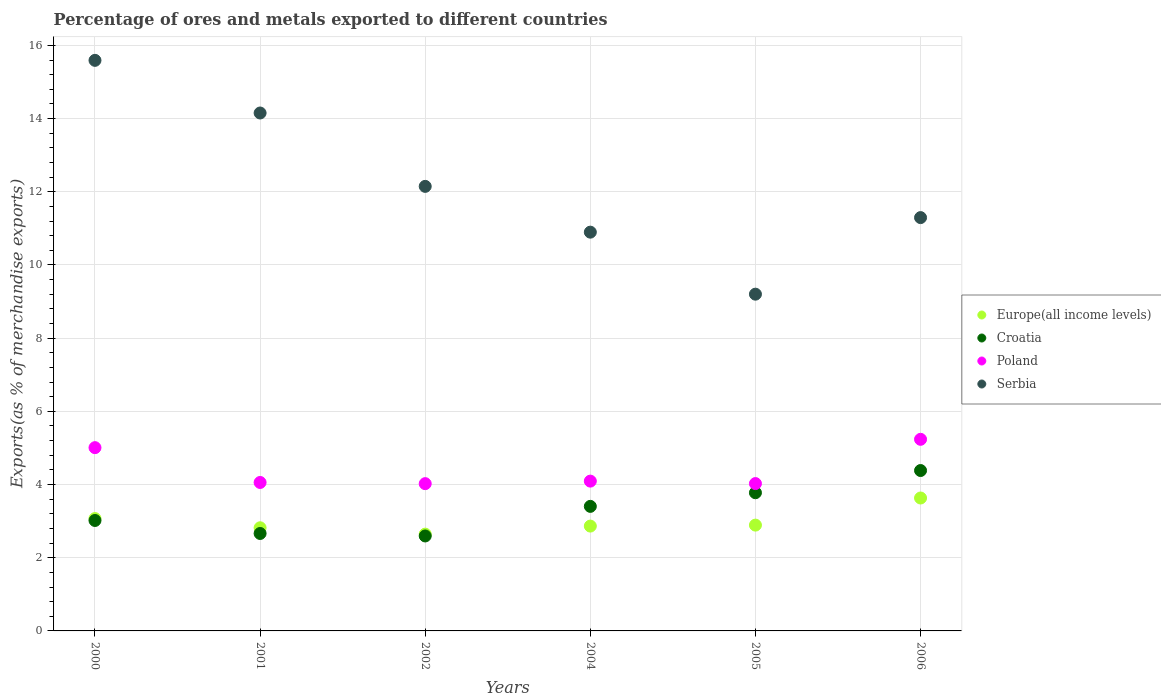Is the number of dotlines equal to the number of legend labels?
Your answer should be compact. Yes. What is the percentage of exports to different countries in Croatia in 2001?
Your response must be concise. 2.66. Across all years, what is the maximum percentage of exports to different countries in Europe(all income levels)?
Your answer should be very brief. 3.63. Across all years, what is the minimum percentage of exports to different countries in Croatia?
Your response must be concise. 2.59. In which year was the percentage of exports to different countries in Croatia maximum?
Keep it short and to the point. 2006. What is the total percentage of exports to different countries in Europe(all income levels) in the graph?
Offer a very short reply. 17.92. What is the difference between the percentage of exports to different countries in Poland in 2002 and that in 2006?
Keep it short and to the point. -1.21. What is the difference between the percentage of exports to different countries in Serbia in 2004 and the percentage of exports to different countries in Europe(all income levels) in 2000?
Keep it short and to the point. 7.83. What is the average percentage of exports to different countries in Poland per year?
Ensure brevity in your answer.  4.41. In the year 2004, what is the difference between the percentage of exports to different countries in Croatia and percentage of exports to different countries in Poland?
Your response must be concise. -0.69. In how many years, is the percentage of exports to different countries in Europe(all income levels) greater than 9.2 %?
Provide a short and direct response. 0. What is the ratio of the percentage of exports to different countries in Croatia in 2004 to that in 2005?
Make the answer very short. 0.9. What is the difference between the highest and the second highest percentage of exports to different countries in Europe(all income levels)?
Provide a succinct answer. 0.56. What is the difference between the highest and the lowest percentage of exports to different countries in Europe(all income levels)?
Offer a very short reply. 0.99. In how many years, is the percentage of exports to different countries in Serbia greater than the average percentage of exports to different countries in Serbia taken over all years?
Ensure brevity in your answer.  2. Is the sum of the percentage of exports to different countries in Poland in 2000 and 2002 greater than the maximum percentage of exports to different countries in Croatia across all years?
Offer a terse response. Yes. Does the percentage of exports to different countries in Croatia monotonically increase over the years?
Your answer should be compact. No. Are the values on the major ticks of Y-axis written in scientific E-notation?
Provide a succinct answer. No. Does the graph contain grids?
Offer a very short reply. Yes. How many legend labels are there?
Provide a succinct answer. 4. How are the legend labels stacked?
Your answer should be compact. Vertical. What is the title of the graph?
Give a very brief answer. Percentage of ores and metals exported to different countries. Does "Cayman Islands" appear as one of the legend labels in the graph?
Give a very brief answer. No. What is the label or title of the Y-axis?
Make the answer very short. Exports(as % of merchandise exports). What is the Exports(as % of merchandise exports) in Europe(all income levels) in 2000?
Your answer should be compact. 3.07. What is the Exports(as % of merchandise exports) in Croatia in 2000?
Offer a very short reply. 3.02. What is the Exports(as % of merchandise exports) of Poland in 2000?
Ensure brevity in your answer.  5.01. What is the Exports(as % of merchandise exports) of Serbia in 2000?
Offer a terse response. 15.59. What is the Exports(as % of merchandise exports) in Europe(all income levels) in 2001?
Make the answer very short. 2.82. What is the Exports(as % of merchandise exports) in Croatia in 2001?
Offer a terse response. 2.66. What is the Exports(as % of merchandise exports) in Poland in 2001?
Provide a short and direct response. 4.06. What is the Exports(as % of merchandise exports) of Serbia in 2001?
Offer a very short reply. 14.15. What is the Exports(as % of merchandise exports) in Europe(all income levels) in 2002?
Offer a very short reply. 2.65. What is the Exports(as % of merchandise exports) of Croatia in 2002?
Keep it short and to the point. 2.59. What is the Exports(as % of merchandise exports) in Poland in 2002?
Provide a short and direct response. 4.02. What is the Exports(as % of merchandise exports) in Serbia in 2002?
Your response must be concise. 12.15. What is the Exports(as % of merchandise exports) in Europe(all income levels) in 2004?
Keep it short and to the point. 2.86. What is the Exports(as % of merchandise exports) in Croatia in 2004?
Your response must be concise. 3.4. What is the Exports(as % of merchandise exports) in Poland in 2004?
Make the answer very short. 4.09. What is the Exports(as % of merchandise exports) in Serbia in 2004?
Keep it short and to the point. 10.9. What is the Exports(as % of merchandise exports) in Europe(all income levels) in 2005?
Make the answer very short. 2.89. What is the Exports(as % of merchandise exports) of Croatia in 2005?
Provide a succinct answer. 3.78. What is the Exports(as % of merchandise exports) in Poland in 2005?
Your answer should be very brief. 4.03. What is the Exports(as % of merchandise exports) in Serbia in 2005?
Your answer should be compact. 9.2. What is the Exports(as % of merchandise exports) of Europe(all income levels) in 2006?
Provide a succinct answer. 3.63. What is the Exports(as % of merchandise exports) in Croatia in 2006?
Offer a terse response. 4.38. What is the Exports(as % of merchandise exports) of Poland in 2006?
Your answer should be very brief. 5.24. What is the Exports(as % of merchandise exports) in Serbia in 2006?
Offer a very short reply. 11.29. Across all years, what is the maximum Exports(as % of merchandise exports) in Europe(all income levels)?
Offer a terse response. 3.63. Across all years, what is the maximum Exports(as % of merchandise exports) in Croatia?
Your answer should be compact. 4.38. Across all years, what is the maximum Exports(as % of merchandise exports) of Poland?
Your answer should be very brief. 5.24. Across all years, what is the maximum Exports(as % of merchandise exports) in Serbia?
Your response must be concise. 15.59. Across all years, what is the minimum Exports(as % of merchandise exports) of Europe(all income levels)?
Offer a terse response. 2.65. Across all years, what is the minimum Exports(as % of merchandise exports) in Croatia?
Keep it short and to the point. 2.59. Across all years, what is the minimum Exports(as % of merchandise exports) of Poland?
Your response must be concise. 4.02. Across all years, what is the minimum Exports(as % of merchandise exports) in Serbia?
Offer a very short reply. 9.2. What is the total Exports(as % of merchandise exports) of Europe(all income levels) in the graph?
Make the answer very short. 17.92. What is the total Exports(as % of merchandise exports) of Croatia in the graph?
Your answer should be compact. 19.84. What is the total Exports(as % of merchandise exports) in Poland in the graph?
Provide a short and direct response. 26.45. What is the total Exports(as % of merchandise exports) of Serbia in the graph?
Ensure brevity in your answer.  73.29. What is the difference between the Exports(as % of merchandise exports) in Europe(all income levels) in 2000 and that in 2001?
Your answer should be very brief. 0.25. What is the difference between the Exports(as % of merchandise exports) of Croatia in 2000 and that in 2001?
Offer a terse response. 0.36. What is the difference between the Exports(as % of merchandise exports) of Poland in 2000 and that in 2001?
Offer a terse response. 0.95. What is the difference between the Exports(as % of merchandise exports) of Serbia in 2000 and that in 2001?
Your response must be concise. 1.44. What is the difference between the Exports(as % of merchandise exports) of Europe(all income levels) in 2000 and that in 2002?
Keep it short and to the point. 0.43. What is the difference between the Exports(as % of merchandise exports) of Croatia in 2000 and that in 2002?
Your response must be concise. 0.42. What is the difference between the Exports(as % of merchandise exports) in Poland in 2000 and that in 2002?
Make the answer very short. 0.98. What is the difference between the Exports(as % of merchandise exports) in Serbia in 2000 and that in 2002?
Provide a succinct answer. 3.44. What is the difference between the Exports(as % of merchandise exports) in Europe(all income levels) in 2000 and that in 2004?
Your answer should be compact. 0.21. What is the difference between the Exports(as % of merchandise exports) in Croatia in 2000 and that in 2004?
Your response must be concise. -0.39. What is the difference between the Exports(as % of merchandise exports) in Poland in 2000 and that in 2004?
Give a very brief answer. 0.91. What is the difference between the Exports(as % of merchandise exports) of Serbia in 2000 and that in 2004?
Ensure brevity in your answer.  4.69. What is the difference between the Exports(as % of merchandise exports) of Europe(all income levels) in 2000 and that in 2005?
Your answer should be very brief. 0.18. What is the difference between the Exports(as % of merchandise exports) in Croatia in 2000 and that in 2005?
Make the answer very short. -0.76. What is the difference between the Exports(as % of merchandise exports) in Poland in 2000 and that in 2005?
Your answer should be very brief. 0.98. What is the difference between the Exports(as % of merchandise exports) in Serbia in 2000 and that in 2005?
Give a very brief answer. 6.39. What is the difference between the Exports(as % of merchandise exports) of Europe(all income levels) in 2000 and that in 2006?
Your answer should be very brief. -0.56. What is the difference between the Exports(as % of merchandise exports) in Croatia in 2000 and that in 2006?
Ensure brevity in your answer.  -1.36. What is the difference between the Exports(as % of merchandise exports) in Poland in 2000 and that in 2006?
Offer a terse response. -0.23. What is the difference between the Exports(as % of merchandise exports) of Serbia in 2000 and that in 2006?
Provide a short and direct response. 4.3. What is the difference between the Exports(as % of merchandise exports) of Europe(all income levels) in 2001 and that in 2002?
Offer a terse response. 0.17. What is the difference between the Exports(as % of merchandise exports) of Croatia in 2001 and that in 2002?
Your answer should be compact. 0.07. What is the difference between the Exports(as % of merchandise exports) of Poland in 2001 and that in 2002?
Provide a short and direct response. 0.03. What is the difference between the Exports(as % of merchandise exports) of Serbia in 2001 and that in 2002?
Make the answer very short. 2.01. What is the difference between the Exports(as % of merchandise exports) of Europe(all income levels) in 2001 and that in 2004?
Provide a succinct answer. -0.05. What is the difference between the Exports(as % of merchandise exports) in Croatia in 2001 and that in 2004?
Keep it short and to the point. -0.74. What is the difference between the Exports(as % of merchandise exports) in Poland in 2001 and that in 2004?
Your answer should be very brief. -0.04. What is the difference between the Exports(as % of merchandise exports) of Serbia in 2001 and that in 2004?
Your answer should be compact. 3.26. What is the difference between the Exports(as % of merchandise exports) in Europe(all income levels) in 2001 and that in 2005?
Your answer should be very brief. -0.07. What is the difference between the Exports(as % of merchandise exports) of Croatia in 2001 and that in 2005?
Offer a terse response. -1.11. What is the difference between the Exports(as % of merchandise exports) in Poland in 2001 and that in 2005?
Provide a succinct answer. 0.03. What is the difference between the Exports(as % of merchandise exports) in Serbia in 2001 and that in 2005?
Your answer should be very brief. 4.95. What is the difference between the Exports(as % of merchandise exports) in Europe(all income levels) in 2001 and that in 2006?
Make the answer very short. -0.81. What is the difference between the Exports(as % of merchandise exports) in Croatia in 2001 and that in 2006?
Make the answer very short. -1.72. What is the difference between the Exports(as % of merchandise exports) in Poland in 2001 and that in 2006?
Give a very brief answer. -1.18. What is the difference between the Exports(as % of merchandise exports) in Serbia in 2001 and that in 2006?
Offer a terse response. 2.86. What is the difference between the Exports(as % of merchandise exports) in Europe(all income levels) in 2002 and that in 2004?
Your response must be concise. -0.22. What is the difference between the Exports(as % of merchandise exports) in Croatia in 2002 and that in 2004?
Keep it short and to the point. -0.81. What is the difference between the Exports(as % of merchandise exports) in Poland in 2002 and that in 2004?
Offer a very short reply. -0.07. What is the difference between the Exports(as % of merchandise exports) in Serbia in 2002 and that in 2004?
Your response must be concise. 1.25. What is the difference between the Exports(as % of merchandise exports) in Europe(all income levels) in 2002 and that in 2005?
Provide a short and direct response. -0.25. What is the difference between the Exports(as % of merchandise exports) of Croatia in 2002 and that in 2005?
Your response must be concise. -1.18. What is the difference between the Exports(as % of merchandise exports) of Poland in 2002 and that in 2005?
Make the answer very short. -0. What is the difference between the Exports(as % of merchandise exports) in Serbia in 2002 and that in 2005?
Offer a terse response. 2.95. What is the difference between the Exports(as % of merchandise exports) of Europe(all income levels) in 2002 and that in 2006?
Give a very brief answer. -0.99. What is the difference between the Exports(as % of merchandise exports) of Croatia in 2002 and that in 2006?
Your answer should be very brief. -1.79. What is the difference between the Exports(as % of merchandise exports) of Poland in 2002 and that in 2006?
Make the answer very short. -1.21. What is the difference between the Exports(as % of merchandise exports) of Serbia in 2002 and that in 2006?
Your response must be concise. 0.85. What is the difference between the Exports(as % of merchandise exports) of Europe(all income levels) in 2004 and that in 2005?
Offer a terse response. -0.03. What is the difference between the Exports(as % of merchandise exports) of Croatia in 2004 and that in 2005?
Provide a succinct answer. -0.37. What is the difference between the Exports(as % of merchandise exports) of Poland in 2004 and that in 2005?
Give a very brief answer. 0.07. What is the difference between the Exports(as % of merchandise exports) in Serbia in 2004 and that in 2005?
Your answer should be very brief. 1.69. What is the difference between the Exports(as % of merchandise exports) of Europe(all income levels) in 2004 and that in 2006?
Keep it short and to the point. -0.77. What is the difference between the Exports(as % of merchandise exports) in Croatia in 2004 and that in 2006?
Give a very brief answer. -0.98. What is the difference between the Exports(as % of merchandise exports) in Poland in 2004 and that in 2006?
Your response must be concise. -1.14. What is the difference between the Exports(as % of merchandise exports) in Serbia in 2004 and that in 2006?
Provide a short and direct response. -0.4. What is the difference between the Exports(as % of merchandise exports) of Europe(all income levels) in 2005 and that in 2006?
Your answer should be very brief. -0.74. What is the difference between the Exports(as % of merchandise exports) of Croatia in 2005 and that in 2006?
Ensure brevity in your answer.  -0.61. What is the difference between the Exports(as % of merchandise exports) of Poland in 2005 and that in 2006?
Make the answer very short. -1.21. What is the difference between the Exports(as % of merchandise exports) of Serbia in 2005 and that in 2006?
Ensure brevity in your answer.  -2.09. What is the difference between the Exports(as % of merchandise exports) in Europe(all income levels) in 2000 and the Exports(as % of merchandise exports) in Croatia in 2001?
Give a very brief answer. 0.41. What is the difference between the Exports(as % of merchandise exports) in Europe(all income levels) in 2000 and the Exports(as % of merchandise exports) in Poland in 2001?
Make the answer very short. -0.99. What is the difference between the Exports(as % of merchandise exports) of Europe(all income levels) in 2000 and the Exports(as % of merchandise exports) of Serbia in 2001?
Offer a terse response. -11.08. What is the difference between the Exports(as % of merchandise exports) in Croatia in 2000 and the Exports(as % of merchandise exports) in Poland in 2001?
Provide a short and direct response. -1.04. What is the difference between the Exports(as % of merchandise exports) of Croatia in 2000 and the Exports(as % of merchandise exports) of Serbia in 2001?
Keep it short and to the point. -11.14. What is the difference between the Exports(as % of merchandise exports) of Poland in 2000 and the Exports(as % of merchandise exports) of Serbia in 2001?
Give a very brief answer. -9.14. What is the difference between the Exports(as % of merchandise exports) in Europe(all income levels) in 2000 and the Exports(as % of merchandise exports) in Croatia in 2002?
Offer a terse response. 0.48. What is the difference between the Exports(as % of merchandise exports) in Europe(all income levels) in 2000 and the Exports(as % of merchandise exports) in Poland in 2002?
Your answer should be very brief. -0.95. What is the difference between the Exports(as % of merchandise exports) in Europe(all income levels) in 2000 and the Exports(as % of merchandise exports) in Serbia in 2002?
Provide a succinct answer. -9.08. What is the difference between the Exports(as % of merchandise exports) in Croatia in 2000 and the Exports(as % of merchandise exports) in Poland in 2002?
Give a very brief answer. -1.01. What is the difference between the Exports(as % of merchandise exports) in Croatia in 2000 and the Exports(as % of merchandise exports) in Serbia in 2002?
Ensure brevity in your answer.  -9.13. What is the difference between the Exports(as % of merchandise exports) in Poland in 2000 and the Exports(as % of merchandise exports) in Serbia in 2002?
Your answer should be compact. -7.14. What is the difference between the Exports(as % of merchandise exports) in Europe(all income levels) in 2000 and the Exports(as % of merchandise exports) in Croatia in 2004?
Offer a terse response. -0.33. What is the difference between the Exports(as % of merchandise exports) in Europe(all income levels) in 2000 and the Exports(as % of merchandise exports) in Poland in 2004?
Keep it short and to the point. -1.02. What is the difference between the Exports(as % of merchandise exports) of Europe(all income levels) in 2000 and the Exports(as % of merchandise exports) of Serbia in 2004?
Your answer should be very brief. -7.83. What is the difference between the Exports(as % of merchandise exports) of Croatia in 2000 and the Exports(as % of merchandise exports) of Poland in 2004?
Provide a short and direct response. -1.08. What is the difference between the Exports(as % of merchandise exports) of Croatia in 2000 and the Exports(as % of merchandise exports) of Serbia in 2004?
Make the answer very short. -7.88. What is the difference between the Exports(as % of merchandise exports) of Poland in 2000 and the Exports(as % of merchandise exports) of Serbia in 2004?
Provide a succinct answer. -5.89. What is the difference between the Exports(as % of merchandise exports) in Europe(all income levels) in 2000 and the Exports(as % of merchandise exports) in Croatia in 2005?
Offer a terse response. -0.71. What is the difference between the Exports(as % of merchandise exports) of Europe(all income levels) in 2000 and the Exports(as % of merchandise exports) of Poland in 2005?
Provide a short and direct response. -0.96. What is the difference between the Exports(as % of merchandise exports) in Europe(all income levels) in 2000 and the Exports(as % of merchandise exports) in Serbia in 2005?
Provide a succinct answer. -6.13. What is the difference between the Exports(as % of merchandise exports) of Croatia in 2000 and the Exports(as % of merchandise exports) of Poland in 2005?
Make the answer very short. -1.01. What is the difference between the Exports(as % of merchandise exports) of Croatia in 2000 and the Exports(as % of merchandise exports) of Serbia in 2005?
Your answer should be compact. -6.18. What is the difference between the Exports(as % of merchandise exports) of Poland in 2000 and the Exports(as % of merchandise exports) of Serbia in 2005?
Offer a terse response. -4.19. What is the difference between the Exports(as % of merchandise exports) of Europe(all income levels) in 2000 and the Exports(as % of merchandise exports) of Croatia in 2006?
Your response must be concise. -1.31. What is the difference between the Exports(as % of merchandise exports) of Europe(all income levels) in 2000 and the Exports(as % of merchandise exports) of Poland in 2006?
Your answer should be very brief. -2.17. What is the difference between the Exports(as % of merchandise exports) of Europe(all income levels) in 2000 and the Exports(as % of merchandise exports) of Serbia in 2006?
Keep it short and to the point. -8.22. What is the difference between the Exports(as % of merchandise exports) of Croatia in 2000 and the Exports(as % of merchandise exports) of Poland in 2006?
Provide a succinct answer. -2.22. What is the difference between the Exports(as % of merchandise exports) of Croatia in 2000 and the Exports(as % of merchandise exports) of Serbia in 2006?
Your response must be concise. -8.28. What is the difference between the Exports(as % of merchandise exports) of Poland in 2000 and the Exports(as % of merchandise exports) of Serbia in 2006?
Your answer should be very brief. -6.29. What is the difference between the Exports(as % of merchandise exports) in Europe(all income levels) in 2001 and the Exports(as % of merchandise exports) in Croatia in 2002?
Provide a short and direct response. 0.22. What is the difference between the Exports(as % of merchandise exports) in Europe(all income levels) in 2001 and the Exports(as % of merchandise exports) in Poland in 2002?
Offer a very short reply. -1.21. What is the difference between the Exports(as % of merchandise exports) of Europe(all income levels) in 2001 and the Exports(as % of merchandise exports) of Serbia in 2002?
Make the answer very short. -9.33. What is the difference between the Exports(as % of merchandise exports) of Croatia in 2001 and the Exports(as % of merchandise exports) of Poland in 2002?
Keep it short and to the point. -1.36. What is the difference between the Exports(as % of merchandise exports) of Croatia in 2001 and the Exports(as % of merchandise exports) of Serbia in 2002?
Make the answer very short. -9.48. What is the difference between the Exports(as % of merchandise exports) of Poland in 2001 and the Exports(as % of merchandise exports) of Serbia in 2002?
Make the answer very short. -8.09. What is the difference between the Exports(as % of merchandise exports) of Europe(all income levels) in 2001 and the Exports(as % of merchandise exports) of Croatia in 2004?
Give a very brief answer. -0.58. What is the difference between the Exports(as % of merchandise exports) of Europe(all income levels) in 2001 and the Exports(as % of merchandise exports) of Poland in 2004?
Offer a terse response. -1.27. What is the difference between the Exports(as % of merchandise exports) of Europe(all income levels) in 2001 and the Exports(as % of merchandise exports) of Serbia in 2004?
Keep it short and to the point. -8.08. What is the difference between the Exports(as % of merchandise exports) in Croatia in 2001 and the Exports(as % of merchandise exports) in Poland in 2004?
Ensure brevity in your answer.  -1.43. What is the difference between the Exports(as % of merchandise exports) in Croatia in 2001 and the Exports(as % of merchandise exports) in Serbia in 2004?
Your answer should be very brief. -8.23. What is the difference between the Exports(as % of merchandise exports) in Poland in 2001 and the Exports(as % of merchandise exports) in Serbia in 2004?
Keep it short and to the point. -6.84. What is the difference between the Exports(as % of merchandise exports) of Europe(all income levels) in 2001 and the Exports(as % of merchandise exports) of Croatia in 2005?
Provide a short and direct response. -0.96. What is the difference between the Exports(as % of merchandise exports) in Europe(all income levels) in 2001 and the Exports(as % of merchandise exports) in Poland in 2005?
Keep it short and to the point. -1.21. What is the difference between the Exports(as % of merchandise exports) of Europe(all income levels) in 2001 and the Exports(as % of merchandise exports) of Serbia in 2005?
Ensure brevity in your answer.  -6.38. What is the difference between the Exports(as % of merchandise exports) in Croatia in 2001 and the Exports(as % of merchandise exports) in Poland in 2005?
Offer a very short reply. -1.36. What is the difference between the Exports(as % of merchandise exports) in Croatia in 2001 and the Exports(as % of merchandise exports) in Serbia in 2005?
Offer a very short reply. -6.54. What is the difference between the Exports(as % of merchandise exports) of Poland in 2001 and the Exports(as % of merchandise exports) of Serbia in 2005?
Provide a short and direct response. -5.15. What is the difference between the Exports(as % of merchandise exports) in Europe(all income levels) in 2001 and the Exports(as % of merchandise exports) in Croatia in 2006?
Offer a very short reply. -1.56. What is the difference between the Exports(as % of merchandise exports) of Europe(all income levels) in 2001 and the Exports(as % of merchandise exports) of Poland in 2006?
Provide a succinct answer. -2.42. What is the difference between the Exports(as % of merchandise exports) of Europe(all income levels) in 2001 and the Exports(as % of merchandise exports) of Serbia in 2006?
Your answer should be compact. -8.48. What is the difference between the Exports(as % of merchandise exports) of Croatia in 2001 and the Exports(as % of merchandise exports) of Poland in 2006?
Give a very brief answer. -2.57. What is the difference between the Exports(as % of merchandise exports) of Croatia in 2001 and the Exports(as % of merchandise exports) of Serbia in 2006?
Provide a succinct answer. -8.63. What is the difference between the Exports(as % of merchandise exports) in Poland in 2001 and the Exports(as % of merchandise exports) in Serbia in 2006?
Offer a very short reply. -7.24. What is the difference between the Exports(as % of merchandise exports) in Europe(all income levels) in 2002 and the Exports(as % of merchandise exports) in Croatia in 2004?
Make the answer very short. -0.76. What is the difference between the Exports(as % of merchandise exports) in Europe(all income levels) in 2002 and the Exports(as % of merchandise exports) in Poland in 2004?
Ensure brevity in your answer.  -1.45. What is the difference between the Exports(as % of merchandise exports) of Europe(all income levels) in 2002 and the Exports(as % of merchandise exports) of Serbia in 2004?
Your answer should be compact. -8.25. What is the difference between the Exports(as % of merchandise exports) in Croatia in 2002 and the Exports(as % of merchandise exports) in Poland in 2004?
Keep it short and to the point. -1.5. What is the difference between the Exports(as % of merchandise exports) in Croatia in 2002 and the Exports(as % of merchandise exports) in Serbia in 2004?
Ensure brevity in your answer.  -8.3. What is the difference between the Exports(as % of merchandise exports) of Poland in 2002 and the Exports(as % of merchandise exports) of Serbia in 2004?
Your answer should be compact. -6.87. What is the difference between the Exports(as % of merchandise exports) in Europe(all income levels) in 2002 and the Exports(as % of merchandise exports) in Croatia in 2005?
Your answer should be compact. -1.13. What is the difference between the Exports(as % of merchandise exports) in Europe(all income levels) in 2002 and the Exports(as % of merchandise exports) in Poland in 2005?
Your answer should be compact. -1.38. What is the difference between the Exports(as % of merchandise exports) of Europe(all income levels) in 2002 and the Exports(as % of merchandise exports) of Serbia in 2005?
Your answer should be very brief. -6.56. What is the difference between the Exports(as % of merchandise exports) in Croatia in 2002 and the Exports(as % of merchandise exports) in Poland in 2005?
Provide a short and direct response. -1.43. What is the difference between the Exports(as % of merchandise exports) of Croatia in 2002 and the Exports(as % of merchandise exports) of Serbia in 2005?
Give a very brief answer. -6.61. What is the difference between the Exports(as % of merchandise exports) in Poland in 2002 and the Exports(as % of merchandise exports) in Serbia in 2005?
Provide a succinct answer. -5.18. What is the difference between the Exports(as % of merchandise exports) of Europe(all income levels) in 2002 and the Exports(as % of merchandise exports) of Croatia in 2006?
Provide a short and direct response. -1.74. What is the difference between the Exports(as % of merchandise exports) of Europe(all income levels) in 2002 and the Exports(as % of merchandise exports) of Poland in 2006?
Ensure brevity in your answer.  -2.59. What is the difference between the Exports(as % of merchandise exports) of Europe(all income levels) in 2002 and the Exports(as % of merchandise exports) of Serbia in 2006?
Offer a terse response. -8.65. What is the difference between the Exports(as % of merchandise exports) of Croatia in 2002 and the Exports(as % of merchandise exports) of Poland in 2006?
Your answer should be very brief. -2.64. What is the difference between the Exports(as % of merchandise exports) of Croatia in 2002 and the Exports(as % of merchandise exports) of Serbia in 2006?
Keep it short and to the point. -8.7. What is the difference between the Exports(as % of merchandise exports) in Poland in 2002 and the Exports(as % of merchandise exports) in Serbia in 2006?
Your response must be concise. -7.27. What is the difference between the Exports(as % of merchandise exports) of Europe(all income levels) in 2004 and the Exports(as % of merchandise exports) of Croatia in 2005?
Ensure brevity in your answer.  -0.91. What is the difference between the Exports(as % of merchandise exports) of Europe(all income levels) in 2004 and the Exports(as % of merchandise exports) of Poland in 2005?
Provide a short and direct response. -1.16. What is the difference between the Exports(as % of merchandise exports) in Europe(all income levels) in 2004 and the Exports(as % of merchandise exports) in Serbia in 2005?
Ensure brevity in your answer.  -6.34. What is the difference between the Exports(as % of merchandise exports) of Croatia in 2004 and the Exports(as % of merchandise exports) of Poland in 2005?
Give a very brief answer. -0.62. What is the difference between the Exports(as % of merchandise exports) in Croatia in 2004 and the Exports(as % of merchandise exports) in Serbia in 2005?
Ensure brevity in your answer.  -5.8. What is the difference between the Exports(as % of merchandise exports) in Poland in 2004 and the Exports(as % of merchandise exports) in Serbia in 2005?
Keep it short and to the point. -5.11. What is the difference between the Exports(as % of merchandise exports) of Europe(all income levels) in 2004 and the Exports(as % of merchandise exports) of Croatia in 2006?
Your answer should be very brief. -1.52. What is the difference between the Exports(as % of merchandise exports) in Europe(all income levels) in 2004 and the Exports(as % of merchandise exports) in Poland in 2006?
Your response must be concise. -2.37. What is the difference between the Exports(as % of merchandise exports) of Europe(all income levels) in 2004 and the Exports(as % of merchandise exports) of Serbia in 2006?
Make the answer very short. -8.43. What is the difference between the Exports(as % of merchandise exports) in Croatia in 2004 and the Exports(as % of merchandise exports) in Poland in 2006?
Give a very brief answer. -1.83. What is the difference between the Exports(as % of merchandise exports) of Croatia in 2004 and the Exports(as % of merchandise exports) of Serbia in 2006?
Make the answer very short. -7.89. What is the difference between the Exports(as % of merchandise exports) in Poland in 2004 and the Exports(as % of merchandise exports) in Serbia in 2006?
Offer a very short reply. -7.2. What is the difference between the Exports(as % of merchandise exports) of Europe(all income levels) in 2005 and the Exports(as % of merchandise exports) of Croatia in 2006?
Provide a succinct answer. -1.49. What is the difference between the Exports(as % of merchandise exports) of Europe(all income levels) in 2005 and the Exports(as % of merchandise exports) of Poland in 2006?
Your response must be concise. -2.34. What is the difference between the Exports(as % of merchandise exports) of Europe(all income levels) in 2005 and the Exports(as % of merchandise exports) of Serbia in 2006?
Ensure brevity in your answer.  -8.4. What is the difference between the Exports(as % of merchandise exports) in Croatia in 2005 and the Exports(as % of merchandise exports) in Poland in 2006?
Provide a succinct answer. -1.46. What is the difference between the Exports(as % of merchandise exports) in Croatia in 2005 and the Exports(as % of merchandise exports) in Serbia in 2006?
Provide a short and direct response. -7.52. What is the difference between the Exports(as % of merchandise exports) in Poland in 2005 and the Exports(as % of merchandise exports) in Serbia in 2006?
Your answer should be compact. -7.27. What is the average Exports(as % of merchandise exports) of Europe(all income levels) per year?
Provide a succinct answer. 2.99. What is the average Exports(as % of merchandise exports) of Croatia per year?
Make the answer very short. 3.31. What is the average Exports(as % of merchandise exports) of Poland per year?
Ensure brevity in your answer.  4.41. What is the average Exports(as % of merchandise exports) of Serbia per year?
Provide a succinct answer. 12.21. In the year 2000, what is the difference between the Exports(as % of merchandise exports) of Europe(all income levels) and Exports(as % of merchandise exports) of Croatia?
Your response must be concise. 0.05. In the year 2000, what is the difference between the Exports(as % of merchandise exports) in Europe(all income levels) and Exports(as % of merchandise exports) in Poland?
Offer a very short reply. -1.94. In the year 2000, what is the difference between the Exports(as % of merchandise exports) of Europe(all income levels) and Exports(as % of merchandise exports) of Serbia?
Make the answer very short. -12.52. In the year 2000, what is the difference between the Exports(as % of merchandise exports) in Croatia and Exports(as % of merchandise exports) in Poland?
Give a very brief answer. -1.99. In the year 2000, what is the difference between the Exports(as % of merchandise exports) in Croatia and Exports(as % of merchandise exports) in Serbia?
Give a very brief answer. -12.57. In the year 2000, what is the difference between the Exports(as % of merchandise exports) of Poland and Exports(as % of merchandise exports) of Serbia?
Your answer should be compact. -10.58. In the year 2001, what is the difference between the Exports(as % of merchandise exports) in Europe(all income levels) and Exports(as % of merchandise exports) in Croatia?
Give a very brief answer. 0.16. In the year 2001, what is the difference between the Exports(as % of merchandise exports) of Europe(all income levels) and Exports(as % of merchandise exports) of Poland?
Make the answer very short. -1.24. In the year 2001, what is the difference between the Exports(as % of merchandise exports) in Europe(all income levels) and Exports(as % of merchandise exports) in Serbia?
Your answer should be compact. -11.33. In the year 2001, what is the difference between the Exports(as % of merchandise exports) of Croatia and Exports(as % of merchandise exports) of Poland?
Provide a short and direct response. -1.39. In the year 2001, what is the difference between the Exports(as % of merchandise exports) of Croatia and Exports(as % of merchandise exports) of Serbia?
Give a very brief answer. -11.49. In the year 2001, what is the difference between the Exports(as % of merchandise exports) in Poland and Exports(as % of merchandise exports) in Serbia?
Your answer should be very brief. -10.1. In the year 2002, what is the difference between the Exports(as % of merchandise exports) in Europe(all income levels) and Exports(as % of merchandise exports) in Croatia?
Keep it short and to the point. 0.05. In the year 2002, what is the difference between the Exports(as % of merchandise exports) in Europe(all income levels) and Exports(as % of merchandise exports) in Poland?
Make the answer very short. -1.38. In the year 2002, what is the difference between the Exports(as % of merchandise exports) in Europe(all income levels) and Exports(as % of merchandise exports) in Serbia?
Provide a succinct answer. -9.5. In the year 2002, what is the difference between the Exports(as % of merchandise exports) in Croatia and Exports(as % of merchandise exports) in Poland?
Offer a terse response. -1.43. In the year 2002, what is the difference between the Exports(as % of merchandise exports) of Croatia and Exports(as % of merchandise exports) of Serbia?
Your response must be concise. -9.55. In the year 2002, what is the difference between the Exports(as % of merchandise exports) in Poland and Exports(as % of merchandise exports) in Serbia?
Provide a short and direct response. -8.12. In the year 2004, what is the difference between the Exports(as % of merchandise exports) of Europe(all income levels) and Exports(as % of merchandise exports) of Croatia?
Ensure brevity in your answer.  -0.54. In the year 2004, what is the difference between the Exports(as % of merchandise exports) of Europe(all income levels) and Exports(as % of merchandise exports) of Poland?
Ensure brevity in your answer.  -1.23. In the year 2004, what is the difference between the Exports(as % of merchandise exports) of Europe(all income levels) and Exports(as % of merchandise exports) of Serbia?
Offer a terse response. -8.03. In the year 2004, what is the difference between the Exports(as % of merchandise exports) in Croatia and Exports(as % of merchandise exports) in Poland?
Keep it short and to the point. -0.69. In the year 2004, what is the difference between the Exports(as % of merchandise exports) of Croatia and Exports(as % of merchandise exports) of Serbia?
Ensure brevity in your answer.  -7.49. In the year 2004, what is the difference between the Exports(as % of merchandise exports) in Poland and Exports(as % of merchandise exports) in Serbia?
Your answer should be very brief. -6.8. In the year 2005, what is the difference between the Exports(as % of merchandise exports) of Europe(all income levels) and Exports(as % of merchandise exports) of Croatia?
Ensure brevity in your answer.  -0.88. In the year 2005, what is the difference between the Exports(as % of merchandise exports) in Europe(all income levels) and Exports(as % of merchandise exports) in Poland?
Your answer should be very brief. -1.14. In the year 2005, what is the difference between the Exports(as % of merchandise exports) in Europe(all income levels) and Exports(as % of merchandise exports) in Serbia?
Your answer should be very brief. -6.31. In the year 2005, what is the difference between the Exports(as % of merchandise exports) of Croatia and Exports(as % of merchandise exports) of Poland?
Make the answer very short. -0.25. In the year 2005, what is the difference between the Exports(as % of merchandise exports) of Croatia and Exports(as % of merchandise exports) of Serbia?
Your response must be concise. -5.43. In the year 2005, what is the difference between the Exports(as % of merchandise exports) in Poland and Exports(as % of merchandise exports) in Serbia?
Give a very brief answer. -5.18. In the year 2006, what is the difference between the Exports(as % of merchandise exports) of Europe(all income levels) and Exports(as % of merchandise exports) of Croatia?
Offer a very short reply. -0.75. In the year 2006, what is the difference between the Exports(as % of merchandise exports) of Europe(all income levels) and Exports(as % of merchandise exports) of Poland?
Ensure brevity in your answer.  -1.6. In the year 2006, what is the difference between the Exports(as % of merchandise exports) in Europe(all income levels) and Exports(as % of merchandise exports) in Serbia?
Give a very brief answer. -7.66. In the year 2006, what is the difference between the Exports(as % of merchandise exports) in Croatia and Exports(as % of merchandise exports) in Poland?
Your response must be concise. -0.85. In the year 2006, what is the difference between the Exports(as % of merchandise exports) in Croatia and Exports(as % of merchandise exports) in Serbia?
Offer a terse response. -6.91. In the year 2006, what is the difference between the Exports(as % of merchandise exports) of Poland and Exports(as % of merchandise exports) of Serbia?
Make the answer very short. -6.06. What is the ratio of the Exports(as % of merchandise exports) in Europe(all income levels) in 2000 to that in 2001?
Provide a short and direct response. 1.09. What is the ratio of the Exports(as % of merchandise exports) in Croatia in 2000 to that in 2001?
Give a very brief answer. 1.13. What is the ratio of the Exports(as % of merchandise exports) of Poland in 2000 to that in 2001?
Your answer should be very brief. 1.23. What is the ratio of the Exports(as % of merchandise exports) of Serbia in 2000 to that in 2001?
Provide a succinct answer. 1.1. What is the ratio of the Exports(as % of merchandise exports) in Europe(all income levels) in 2000 to that in 2002?
Provide a succinct answer. 1.16. What is the ratio of the Exports(as % of merchandise exports) in Croatia in 2000 to that in 2002?
Provide a short and direct response. 1.16. What is the ratio of the Exports(as % of merchandise exports) in Poland in 2000 to that in 2002?
Your answer should be compact. 1.24. What is the ratio of the Exports(as % of merchandise exports) in Serbia in 2000 to that in 2002?
Your response must be concise. 1.28. What is the ratio of the Exports(as % of merchandise exports) of Europe(all income levels) in 2000 to that in 2004?
Offer a very short reply. 1.07. What is the ratio of the Exports(as % of merchandise exports) in Croatia in 2000 to that in 2004?
Your answer should be very brief. 0.89. What is the ratio of the Exports(as % of merchandise exports) in Poland in 2000 to that in 2004?
Offer a very short reply. 1.22. What is the ratio of the Exports(as % of merchandise exports) in Serbia in 2000 to that in 2004?
Give a very brief answer. 1.43. What is the ratio of the Exports(as % of merchandise exports) of Europe(all income levels) in 2000 to that in 2005?
Offer a very short reply. 1.06. What is the ratio of the Exports(as % of merchandise exports) of Croatia in 2000 to that in 2005?
Provide a succinct answer. 0.8. What is the ratio of the Exports(as % of merchandise exports) in Poland in 2000 to that in 2005?
Make the answer very short. 1.24. What is the ratio of the Exports(as % of merchandise exports) of Serbia in 2000 to that in 2005?
Provide a succinct answer. 1.69. What is the ratio of the Exports(as % of merchandise exports) of Europe(all income levels) in 2000 to that in 2006?
Your response must be concise. 0.85. What is the ratio of the Exports(as % of merchandise exports) of Croatia in 2000 to that in 2006?
Your response must be concise. 0.69. What is the ratio of the Exports(as % of merchandise exports) of Poland in 2000 to that in 2006?
Your answer should be compact. 0.96. What is the ratio of the Exports(as % of merchandise exports) in Serbia in 2000 to that in 2006?
Offer a very short reply. 1.38. What is the ratio of the Exports(as % of merchandise exports) in Europe(all income levels) in 2001 to that in 2002?
Your answer should be compact. 1.07. What is the ratio of the Exports(as % of merchandise exports) of Croatia in 2001 to that in 2002?
Your answer should be compact. 1.03. What is the ratio of the Exports(as % of merchandise exports) in Poland in 2001 to that in 2002?
Your answer should be compact. 1.01. What is the ratio of the Exports(as % of merchandise exports) of Serbia in 2001 to that in 2002?
Your answer should be compact. 1.17. What is the ratio of the Exports(as % of merchandise exports) of Europe(all income levels) in 2001 to that in 2004?
Your response must be concise. 0.98. What is the ratio of the Exports(as % of merchandise exports) of Croatia in 2001 to that in 2004?
Keep it short and to the point. 0.78. What is the ratio of the Exports(as % of merchandise exports) in Serbia in 2001 to that in 2004?
Keep it short and to the point. 1.3. What is the ratio of the Exports(as % of merchandise exports) in Europe(all income levels) in 2001 to that in 2005?
Make the answer very short. 0.97. What is the ratio of the Exports(as % of merchandise exports) in Croatia in 2001 to that in 2005?
Give a very brief answer. 0.71. What is the ratio of the Exports(as % of merchandise exports) in Poland in 2001 to that in 2005?
Your answer should be compact. 1.01. What is the ratio of the Exports(as % of merchandise exports) in Serbia in 2001 to that in 2005?
Make the answer very short. 1.54. What is the ratio of the Exports(as % of merchandise exports) of Europe(all income levels) in 2001 to that in 2006?
Keep it short and to the point. 0.78. What is the ratio of the Exports(as % of merchandise exports) in Croatia in 2001 to that in 2006?
Your answer should be compact. 0.61. What is the ratio of the Exports(as % of merchandise exports) of Poland in 2001 to that in 2006?
Your response must be concise. 0.77. What is the ratio of the Exports(as % of merchandise exports) of Serbia in 2001 to that in 2006?
Give a very brief answer. 1.25. What is the ratio of the Exports(as % of merchandise exports) in Europe(all income levels) in 2002 to that in 2004?
Your answer should be very brief. 0.92. What is the ratio of the Exports(as % of merchandise exports) of Croatia in 2002 to that in 2004?
Your answer should be very brief. 0.76. What is the ratio of the Exports(as % of merchandise exports) in Poland in 2002 to that in 2004?
Your answer should be compact. 0.98. What is the ratio of the Exports(as % of merchandise exports) in Serbia in 2002 to that in 2004?
Your response must be concise. 1.11. What is the ratio of the Exports(as % of merchandise exports) of Europe(all income levels) in 2002 to that in 2005?
Your response must be concise. 0.91. What is the ratio of the Exports(as % of merchandise exports) of Croatia in 2002 to that in 2005?
Offer a very short reply. 0.69. What is the ratio of the Exports(as % of merchandise exports) of Serbia in 2002 to that in 2005?
Provide a short and direct response. 1.32. What is the ratio of the Exports(as % of merchandise exports) of Europe(all income levels) in 2002 to that in 2006?
Keep it short and to the point. 0.73. What is the ratio of the Exports(as % of merchandise exports) in Croatia in 2002 to that in 2006?
Your response must be concise. 0.59. What is the ratio of the Exports(as % of merchandise exports) in Poland in 2002 to that in 2006?
Your answer should be very brief. 0.77. What is the ratio of the Exports(as % of merchandise exports) of Serbia in 2002 to that in 2006?
Offer a very short reply. 1.08. What is the ratio of the Exports(as % of merchandise exports) of Croatia in 2004 to that in 2005?
Give a very brief answer. 0.9. What is the ratio of the Exports(as % of merchandise exports) in Poland in 2004 to that in 2005?
Provide a succinct answer. 1.02. What is the ratio of the Exports(as % of merchandise exports) in Serbia in 2004 to that in 2005?
Your answer should be compact. 1.18. What is the ratio of the Exports(as % of merchandise exports) of Europe(all income levels) in 2004 to that in 2006?
Ensure brevity in your answer.  0.79. What is the ratio of the Exports(as % of merchandise exports) of Croatia in 2004 to that in 2006?
Your answer should be very brief. 0.78. What is the ratio of the Exports(as % of merchandise exports) of Poland in 2004 to that in 2006?
Make the answer very short. 0.78. What is the ratio of the Exports(as % of merchandise exports) of Serbia in 2004 to that in 2006?
Provide a succinct answer. 0.96. What is the ratio of the Exports(as % of merchandise exports) in Europe(all income levels) in 2005 to that in 2006?
Keep it short and to the point. 0.8. What is the ratio of the Exports(as % of merchandise exports) in Croatia in 2005 to that in 2006?
Offer a very short reply. 0.86. What is the ratio of the Exports(as % of merchandise exports) in Poland in 2005 to that in 2006?
Give a very brief answer. 0.77. What is the ratio of the Exports(as % of merchandise exports) of Serbia in 2005 to that in 2006?
Your answer should be compact. 0.81. What is the difference between the highest and the second highest Exports(as % of merchandise exports) of Europe(all income levels)?
Provide a succinct answer. 0.56. What is the difference between the highest and the second highest Exports(as % of merchandise exports) of Croatia?
Ensure brevity in your answer.  0.61. What is the difference between the highest and the second highest Exports(as % of merchandise exports) in Poland?
Keep it short and to the point. 0.23. What is the difference between the highest and the second highest Exports(as % of merchandise exports) in Serbia?
Your response must be concise. 1.44. What is the difference between the highest and the lowest Exports(as % of merchandise exports) in Europe(all income levels)?
Your answer should be very brief. 0.99. What is the difference between the highest and the lowest Exports(as % of merchandise exports) of Croatia?
Your answer should be very brief. 1.79. What is the difference between the highest and the lowest Exports(as % of merchandise exports) in Poland?
Your answer should be compact. 1.21. What is the difference between the highest and the lowest Exports(as % of merchandise exports) of Serbia?
Offer a terse response. 6.39. 